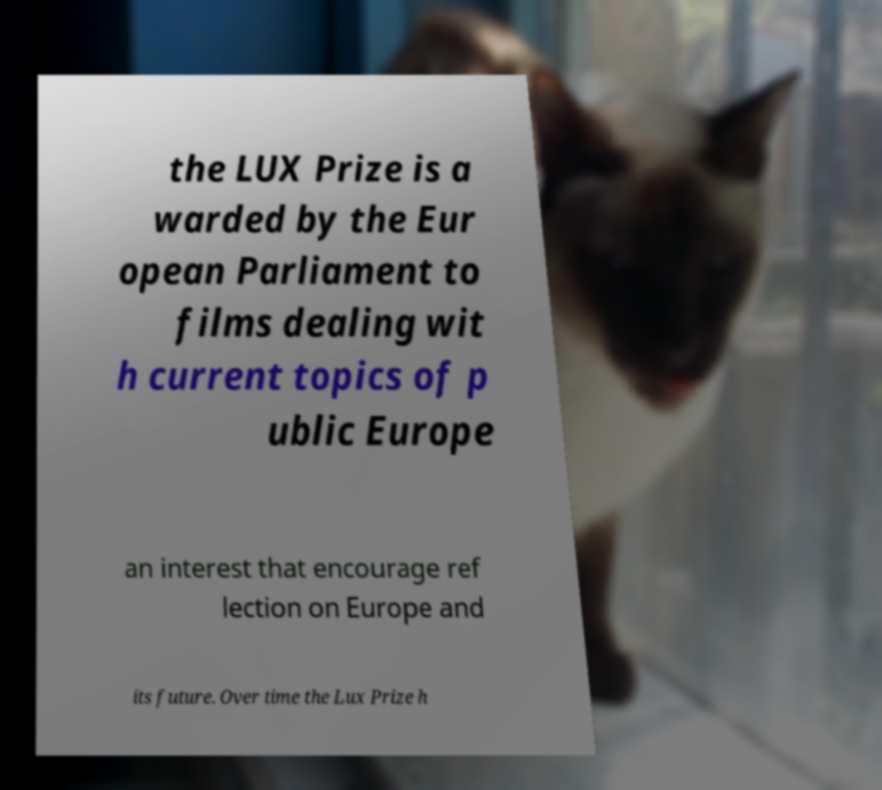Can you read and provide the text displayed in the image?This photo seems to have some interesting text. Can you extract and type it out for me? the LUX Prize is a warded by the Eur opean Parliament to films dealing wit h current topics of p ublic Europe an interest that encourage ref lection on Europe and its future. Over time the Lux Prize h 